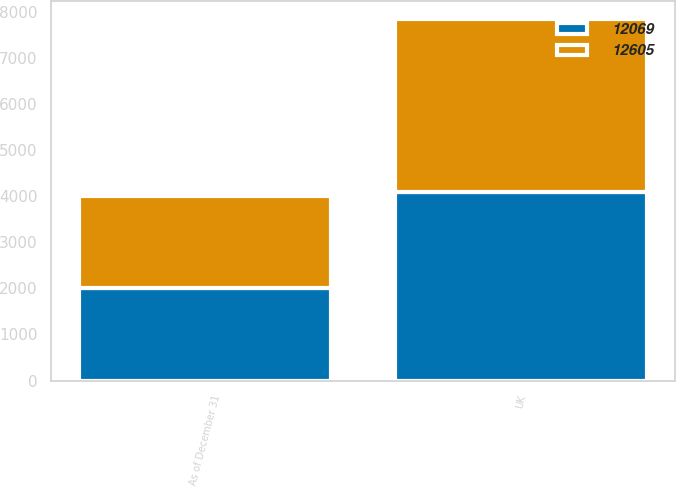Convert chart to OTSL. <chart><loc_0><loc_0><loc_500><loc_500><stacked_bar_chart><ecel><fcel>As of December 31<fcel>UK<nl><fcel>12069<fcel>2007<fcel>4092<nl><fcel>12605<fcel>2006<fcel>3755<nl></chart> 